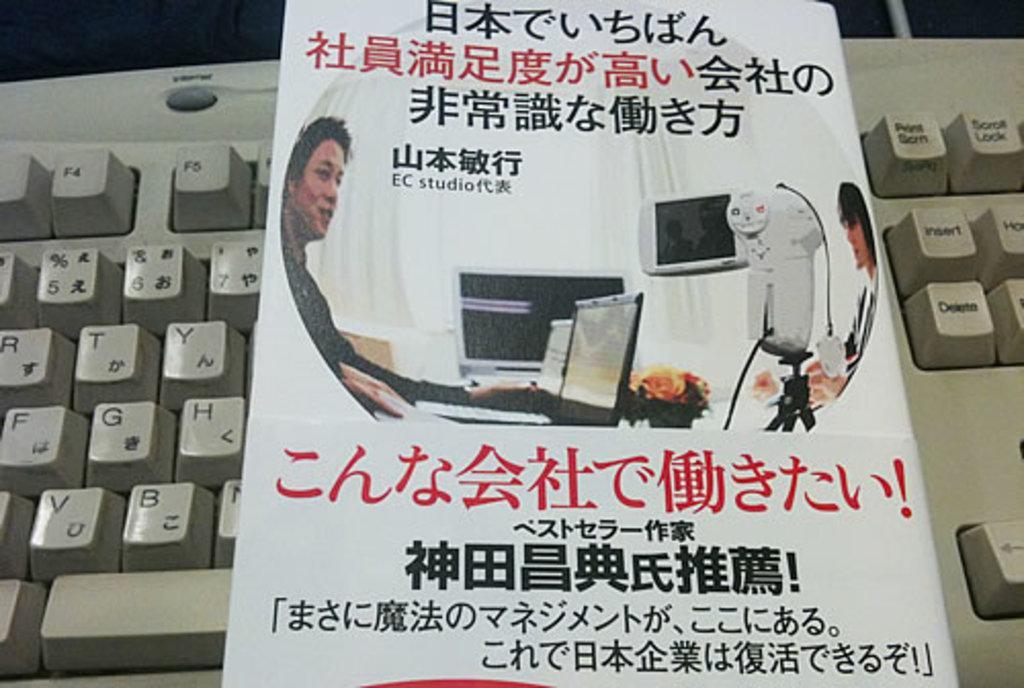Please provide a concise description of this image. In this image I can see a white colour keyboard and on it I can see a white colour thing. I can also see something is written on this object. 